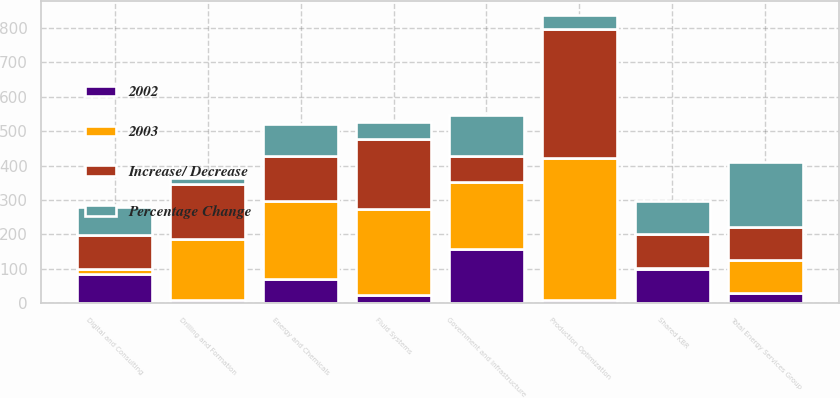Convert chart. <chart><loc_0><loc_0><loc_500><loc_500><stacked_bar_chart><ecel><fcel>Production Optimization<fcel>Fluid Systems<fcel>Drilling and Formation<fcel>Digital and Consulting<fcel>Total Energy Services Group<fcel>Government and Infrastructure<fcel>Energy and Chemicals<fcel>Shared KBR<nl><fcel>2003<fcel>413<fcel>251<fcel>177<fcel>15<fcel>96<fcel>194<fcel>225<fcel>5<nl><fcel>Increase/ Decrease<fcel>374<fcel>202<fcel>160<fcel>98<fcel>96<fcel>75<fcel>131<fcel>96<nl><fcel>Percentage Change<fcel>39<fcel>49<fcel>17<fcel>83<fcel>188<fcel>119<fcel>94<fcel>96<nl><fcel>2002<fcel>10<fcel>24<fcel>11<fcel>85<fcel>29<fcel>159<fcel>72<fcel>99<nl></chart> 